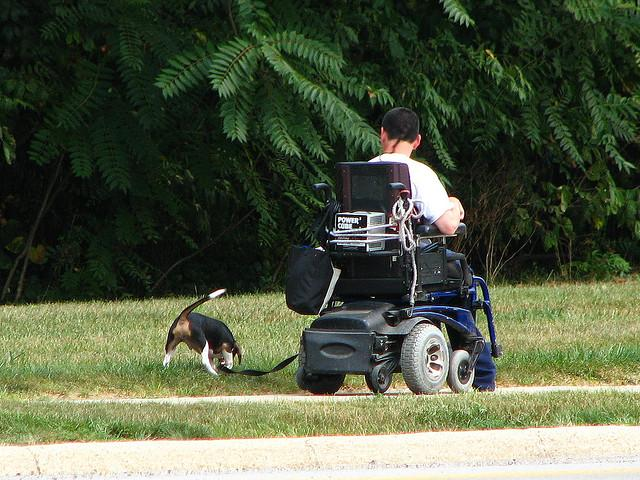What is the purpose of the power cube on the back of the wheelchair? Please explain your reasoning. move it. It is a battery to run the motor 